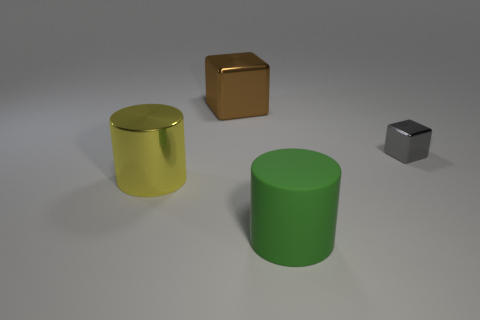What number of yellow objects are small rubber balls or large cubes?
Your answer should be compact. 0. What number of metallic blocks have the same color as the big rubber thing?
Make the answer very short. 0. Is there any other thing that has the same shape as the green object?
Provide a succinct answer. Yes. How many cylinders are tiny blue shiny things or gray metal things?
Give a very brief answer. 0. The block on the right side of the large shiny block is what color?
Your answer should be compact. Gray. There is a yellow thing that is the same size as the green object; what shape is it?
Offer a very short reply. Cylinder. There is a green cylinder; what number of green matte things are in front of it?
Ensure brevity in your answer.  0. What number of objects are large brown matte things or big cylinders?
Give a very brief answer. 2. The metal object that is in front of the large brown thing and behind the yellow cylinder has what shape?
Your answer should be very brief. Cube. What number of big purple cylinders are there?
Your answer should be compact. 0. 